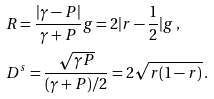<formula> <loc_0><loc_0><loc_500><loc_500>& R = \frac { | \gamma - P | } { \gamma + P } g = 2 | r - \frac { 1 } { 2 } | g \, , \\ & D ^ { s } = \frac { \sqrt { \gamma P } } { ( \gamma + P ) / 2 } = 2 \sqrt { r ( 1 - r ) } \, .</formula> 